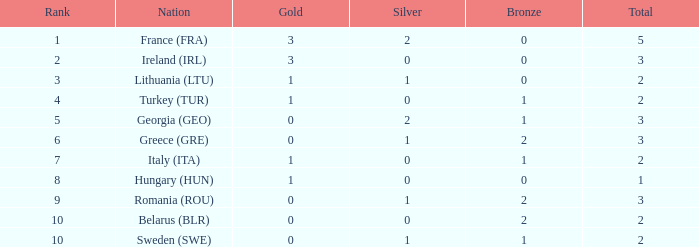Help me parse the entirety of this table. {'header': ['Rank', 'Nation', 'Gold', 'Silver', 'Bronze', 'Total'], 'rows': [['1', 'France (FRA)', '3', '2', '0', '5'], ['2', 'Ireland (IRL)', '3', '0', '0', '3'], ['3', 'Lithuania (LTU)', '1', '1', '0', '2'], ['4', 'Turkey (TUR)', '1', '0', '1', '2'], ['5', 'Georgia (GEO)', '0', '2', '1', '3'], ['6', 'Greece (GRE)', '0', '1', '2', '3'], ['7', 'Italy (ITA)', '1', '0', '1', '2'], ['8', 'Hungary (HUN)', '1', '0', '0', '1'], ['9', 'Romania (ROU)', '0', '1', '2', '3'], ['10', 'Belarus (BLR)', '0', '0', '2', '2'], ['10', 'Sweden (SWE)', '0', '1', '1', '2']]} What's the rank of Turkey (TUR) with a total more than 2? 0.0. 